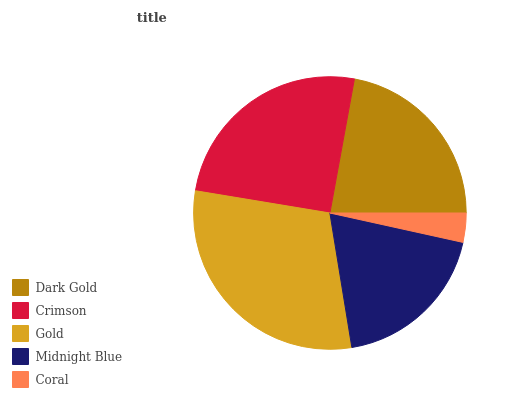Is Coral the minimum?
Answer yes or no. Yes. Is Gold the maximum?
Answer yes or no. Yes. Is Crimson the minimum?
Answer yes or no. No. Is Crimson the maximum?
Answer yes or no. No. Is Crimson greater than Dark Gold?
Answer yes or no. Yes. Is Dark Gold less than Crimson?
Answer yes or no. Yes. Is Dark Gold greater than Crimson?
Answer yes or no. No. Is Crimson less than Dark Gold?
Answer yes or no. No. Is Dark Gold the high median?
Answer yes or no. Yes. Is Dark Gold the low median?
Answer yes or no. Yes. Is Midnight Blue the high median?
Answer yes or no. No. Is Midnight Blue the low median?
Answer yes or no. No. 